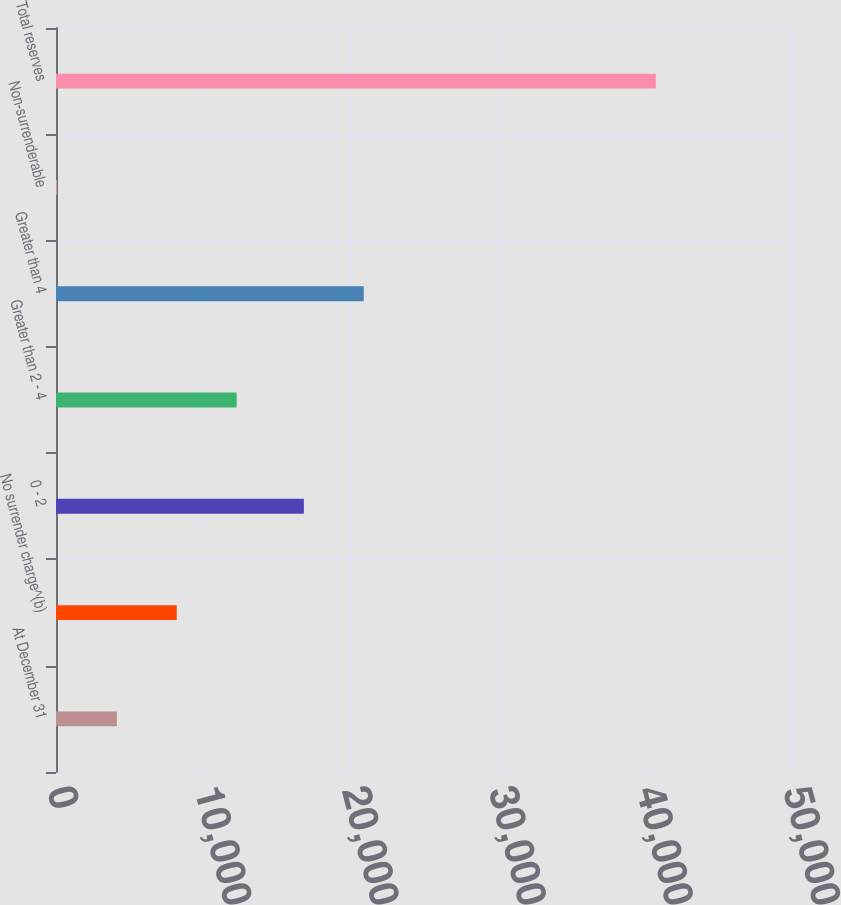Convert chart to OTSL. <chart><loc_0><loc_0><loc_500><loc_500><bar_chart><fcel>At December 31<fcel>No surrender charge^(b)<fcel>0 - 2<fcel>Greater than 2 - 4<fcel>Greater than 4<fcel>Non-surrenderable<fcel>Total reserves<nl><fcel>4134.7<fcel>8202.4<fcel>16839<fcel>12270.1<fcel>20906.7<fcel>67<fcel>40744<nl></chart> 